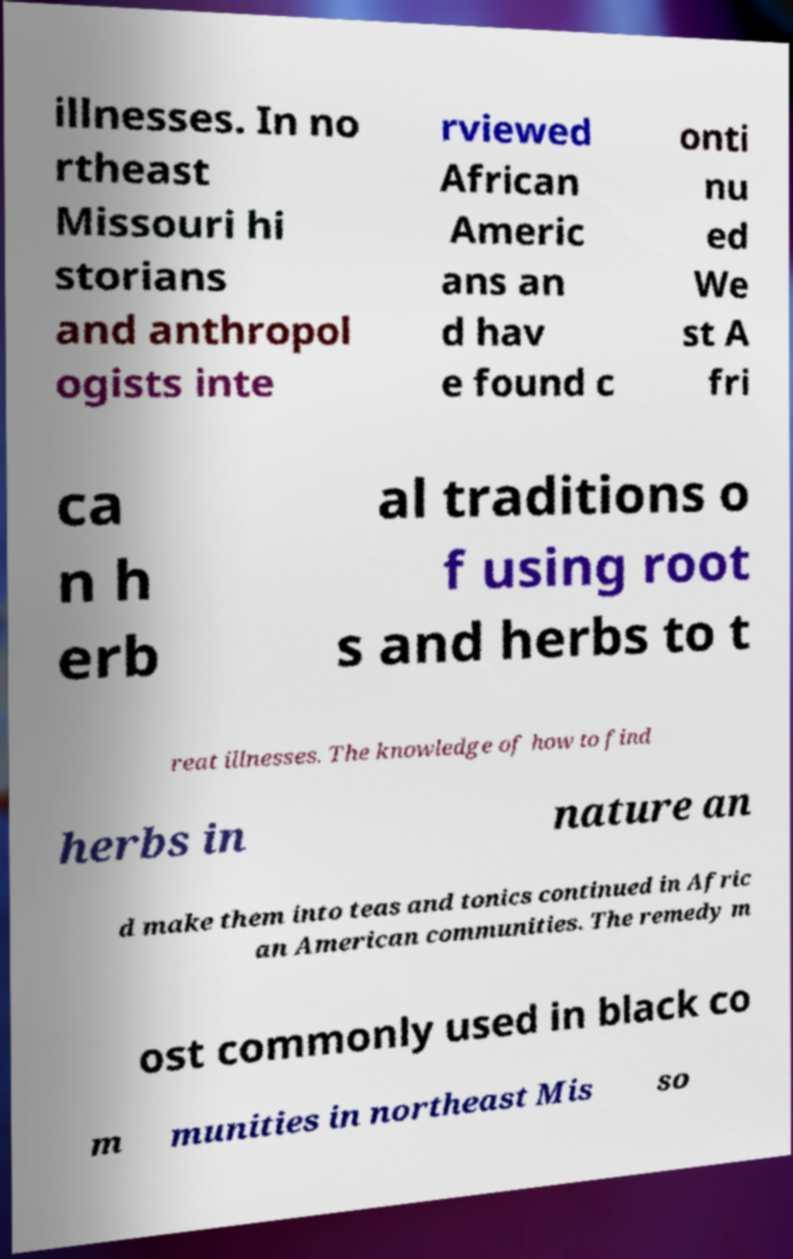There's text embedded in this image that I need extracted. Can you transcribe it verbatim? illnesses. In no rtheast Missouri hi storians and anthropol ogists inte rviewed African Americ ans an d hav e found c onti nu ed We st A fri ca n h erb al traditions o f using root s and herbs to t reat illnesses. The knowledge of how to find herbs in nature an d make them into teas and tonics continued in Afric an American communities. The remedy m ost commonly used in black co m munities in northeast Mis so 